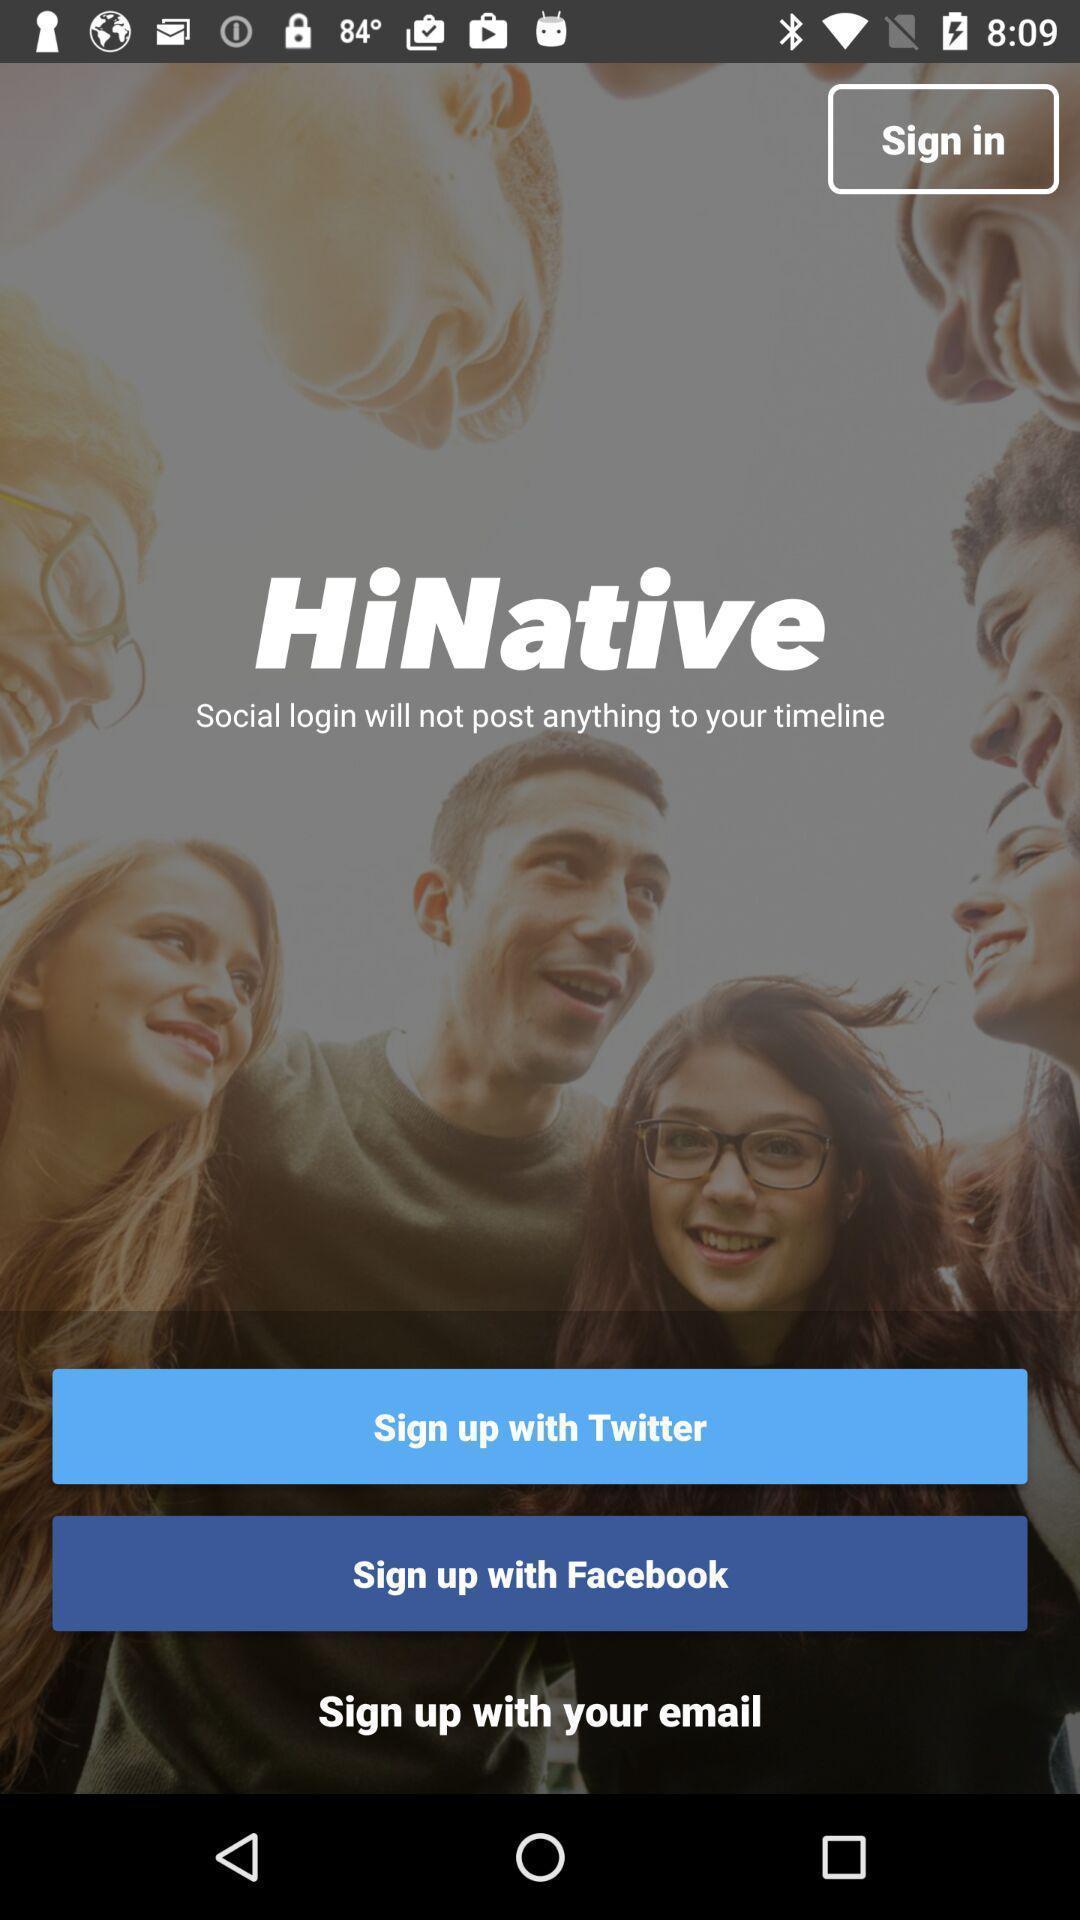Summarize the main components in this picture. Welcome page of social media app. 